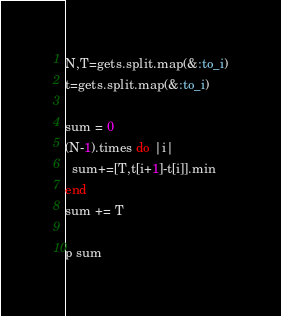<code> <loc_0><loc_0><loc_500><loc_500><_Ruby_>N,T=gets.split.map(&:to_i)
t=gets.split.map(&:to_i)

sum = 0
(N-1).times do |i|
  sum+=[T,t[i+1]-t[i]].min
end
sum += T

p sum </code> 